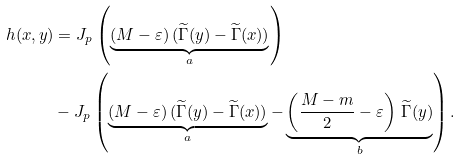Convert formula to latex. <formula><loc_0><loc_0><loc_500><loc_500>h ( x , y ) & = J _ { p } \left ( \underbrace { ( M - \varepsilon ) \, ( \widetilde { \Gamma } ( y ) - \widetilde { \Gamma } ( x ) ) } _ { a } \right ) \\ & - J _ { p } \left ( \underbrace { ( M - \varepsilon ) \, ( \widetilde { \Gamma } ( y ) - \widetilde { \Gamma } ( x ) ) } _ { a } - \underbrace { \left ( \frac { M - m } { 2 } - \varepsilon \right ) \, \widetilde { \Gamma } ( y ) } _ { b } \right ) .</formula> 